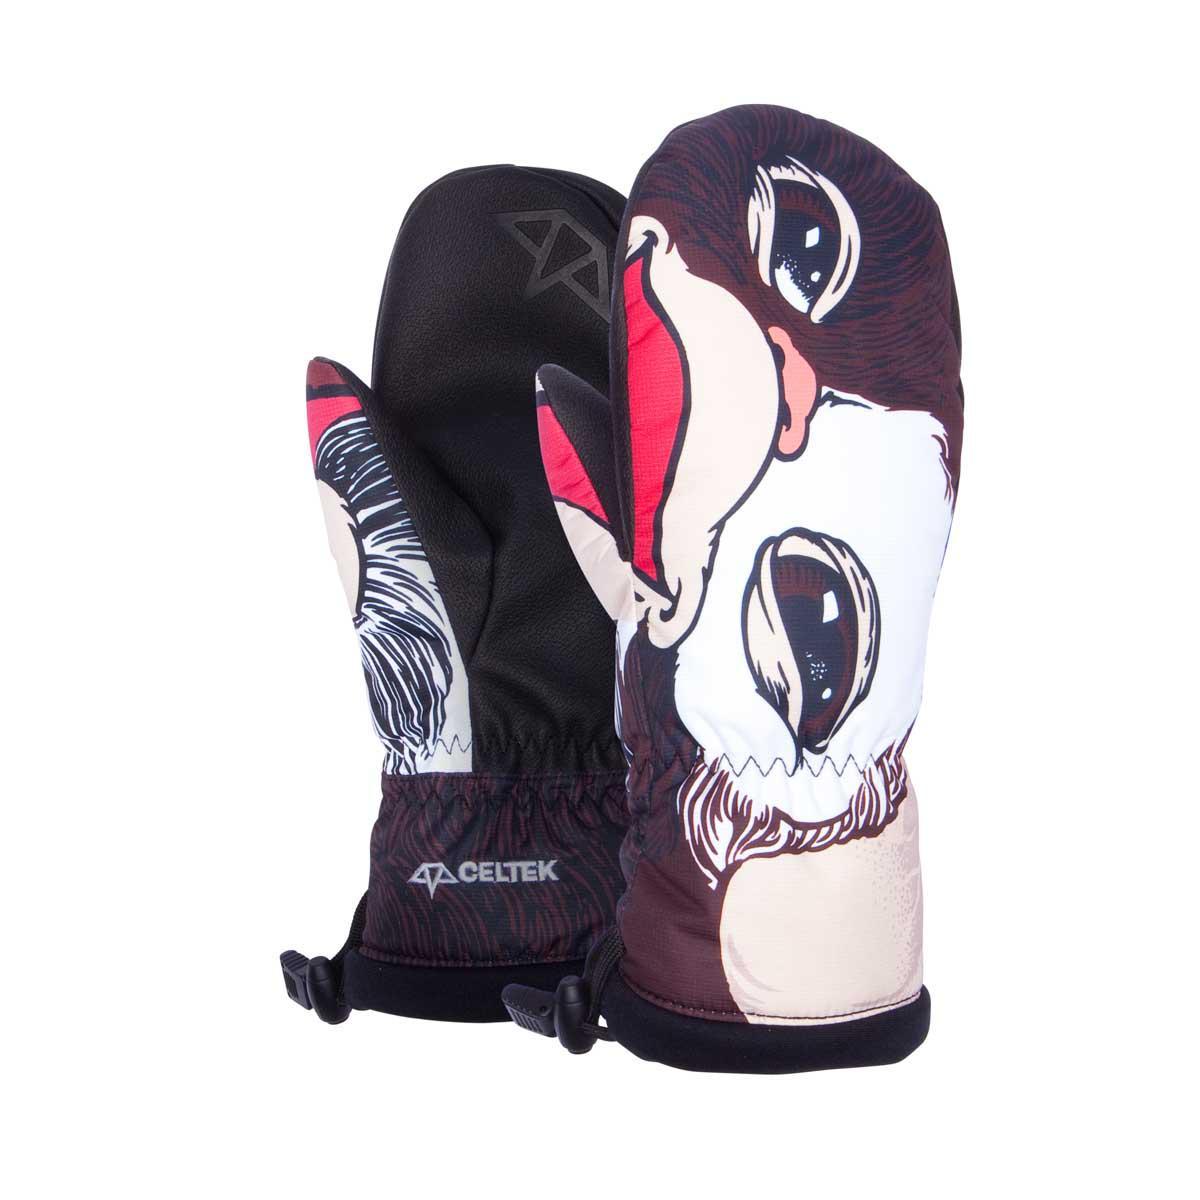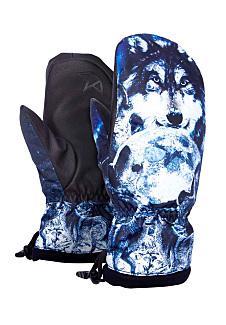The first image is the image on the left, the second image is the image on the right. Evaluate the accuracy of this statement regarding the images: "Each image shows one pair of mittens, and one of the mitten pairs has a realistic black-and-white nonhuman animal face depicted on its non-palm side.". Is it true? Answer yes or no. Yes. The first image is the image on the left, the second image is the image on the right. Examine the images to the left and right. Is the description "The pattern on the mittens in the image on the right depict a nonhuman animal." accurate? Answer yes or no. Yes. 